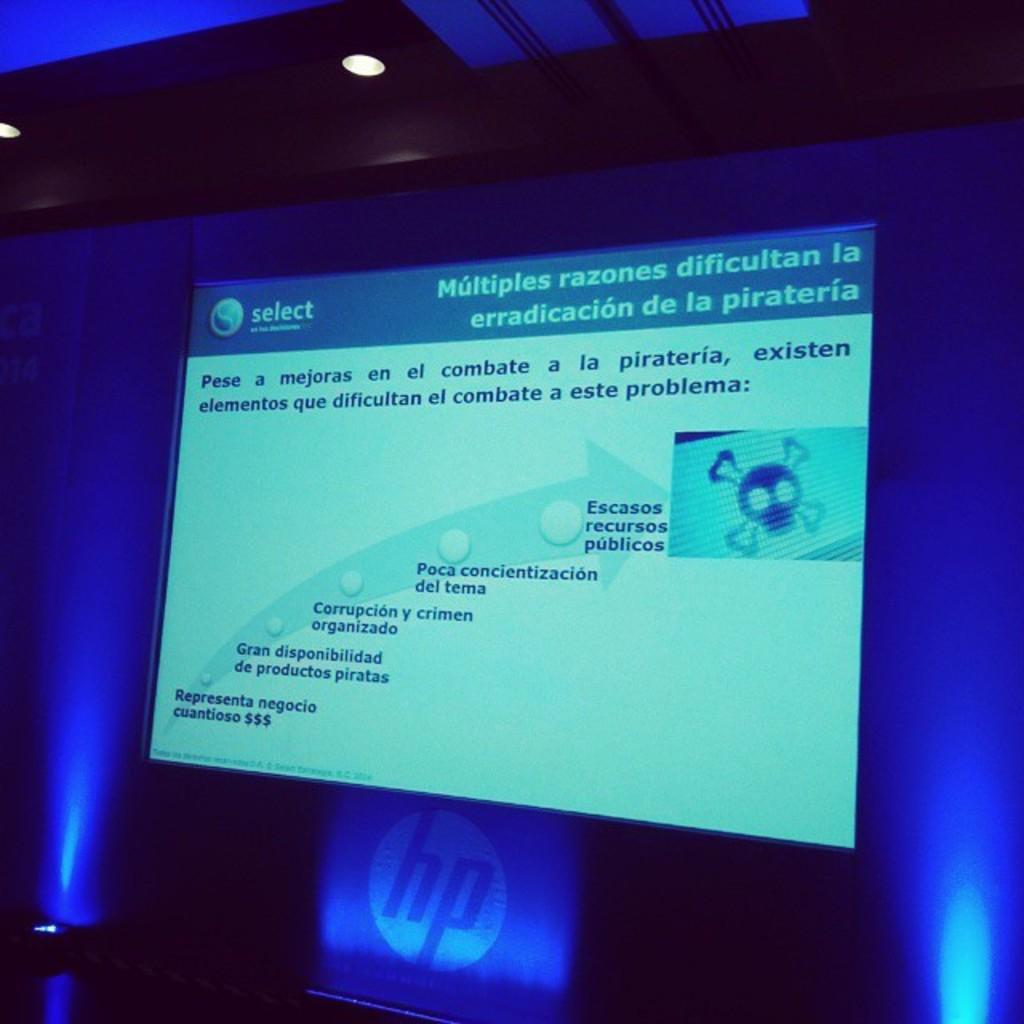Provide a one-sentence caption for the provided image. The Spanish presentation is displayed on a HP computer. 